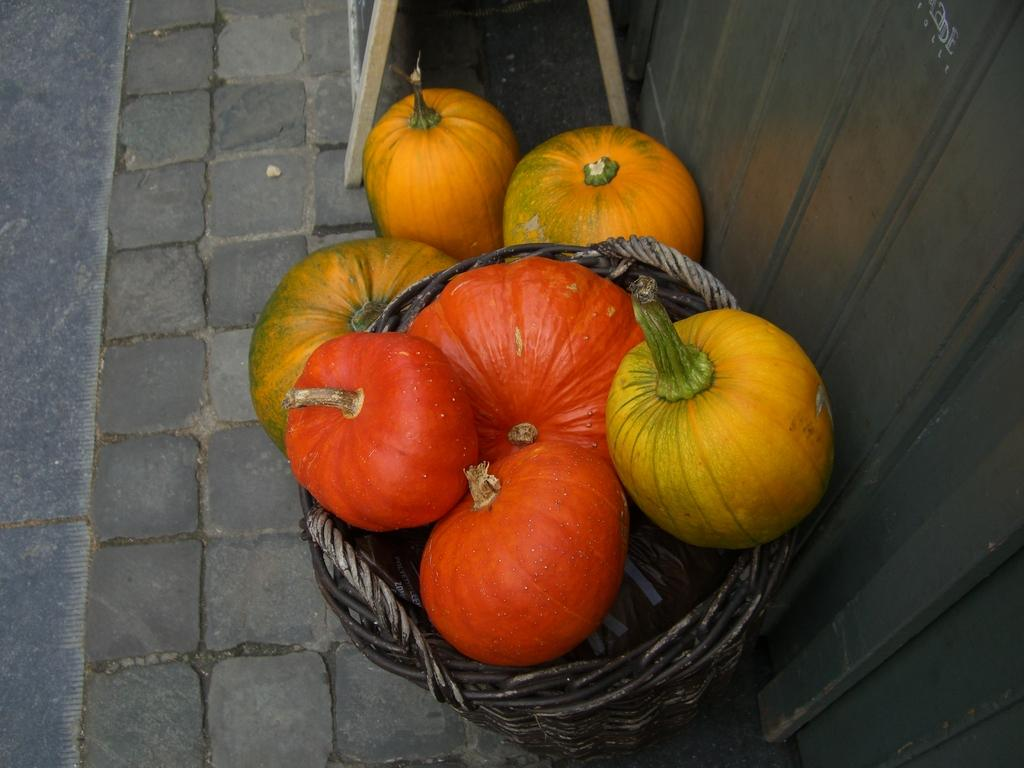What type of objects are in the basket in the image? There are pumpkins in a basket in the image. Can you describe any other objects visible in the image? Unfortunately, the provided facts only mention that there are other objects visible in the image, but no specific details are given. What type of root is growing out of the pumpkin in the image? There is no root growing out of the pumpkin in the image, as pumpkins are not plants and do not have roots. What type of ornament is hanging from the airplane in the image? There is no airplane present in the image, so it is not possible to answer a question about an ornament hanging from it. 